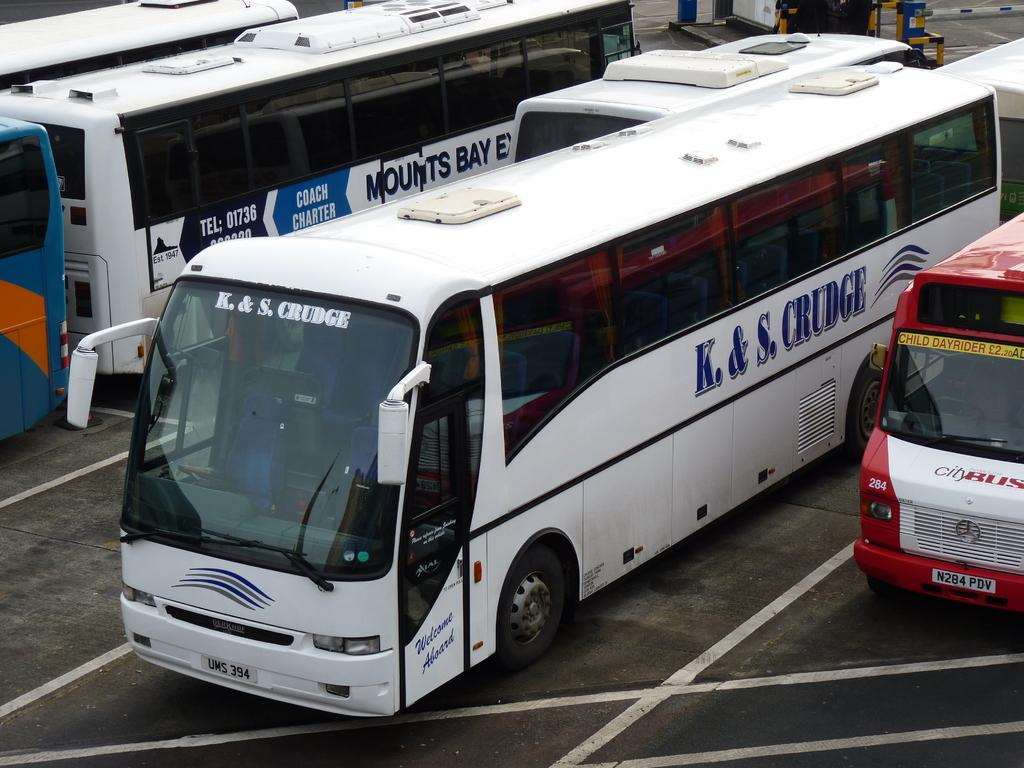<image>
Describe the image concisely. The K. & S Crudge bus is parked near several other busses. 